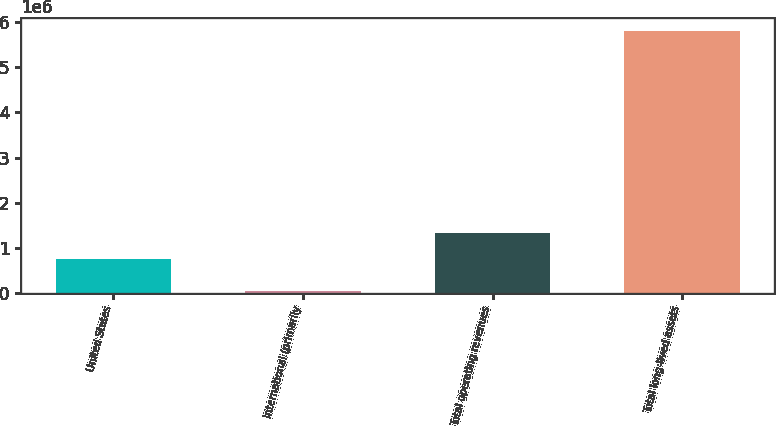Convert chart. <chart><loc_0><loc_0><loc_500><loc_500><bar_chart><fcel>United States<fcel>International (primarily<fcel>Total operating revenues<fcel>Total long-lived assets<nl><fcel>744486<fcel>40664<fcel>1.31997e+06<fcel>5.79548e+06<nl></chart> 